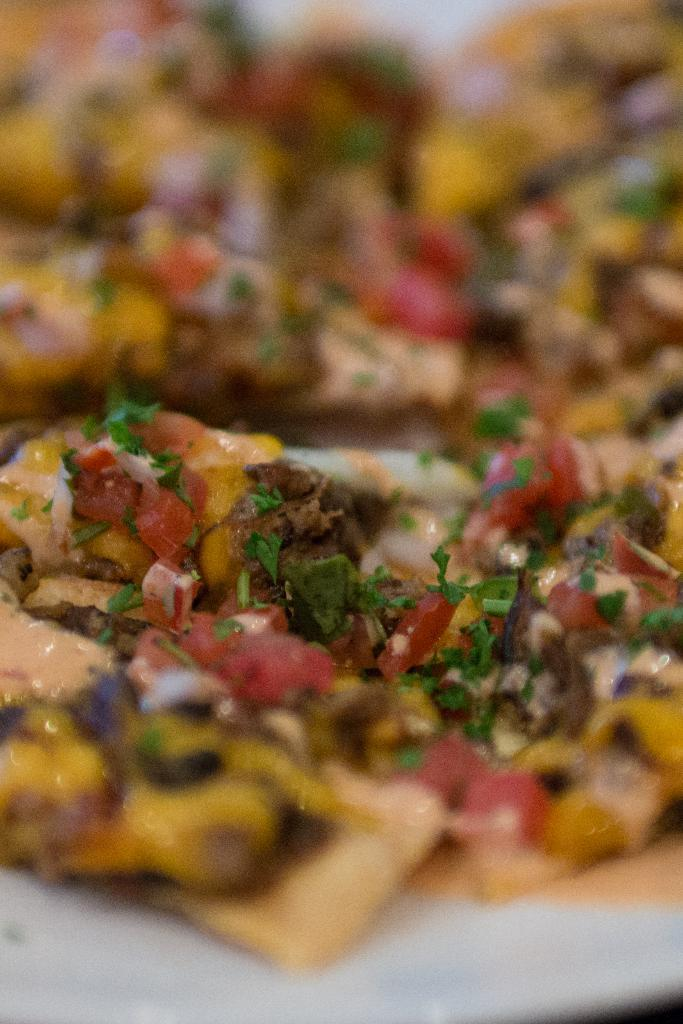What is present in the image? There is food in the image. What type of fireman is shown helping with the birth in the image? There is no fireman or birth depicted in the image; it only features food. How many bites have been taken out of the food in the image? The number of bites cannot be determined from the image, as it only shows the food and not any consumption. 